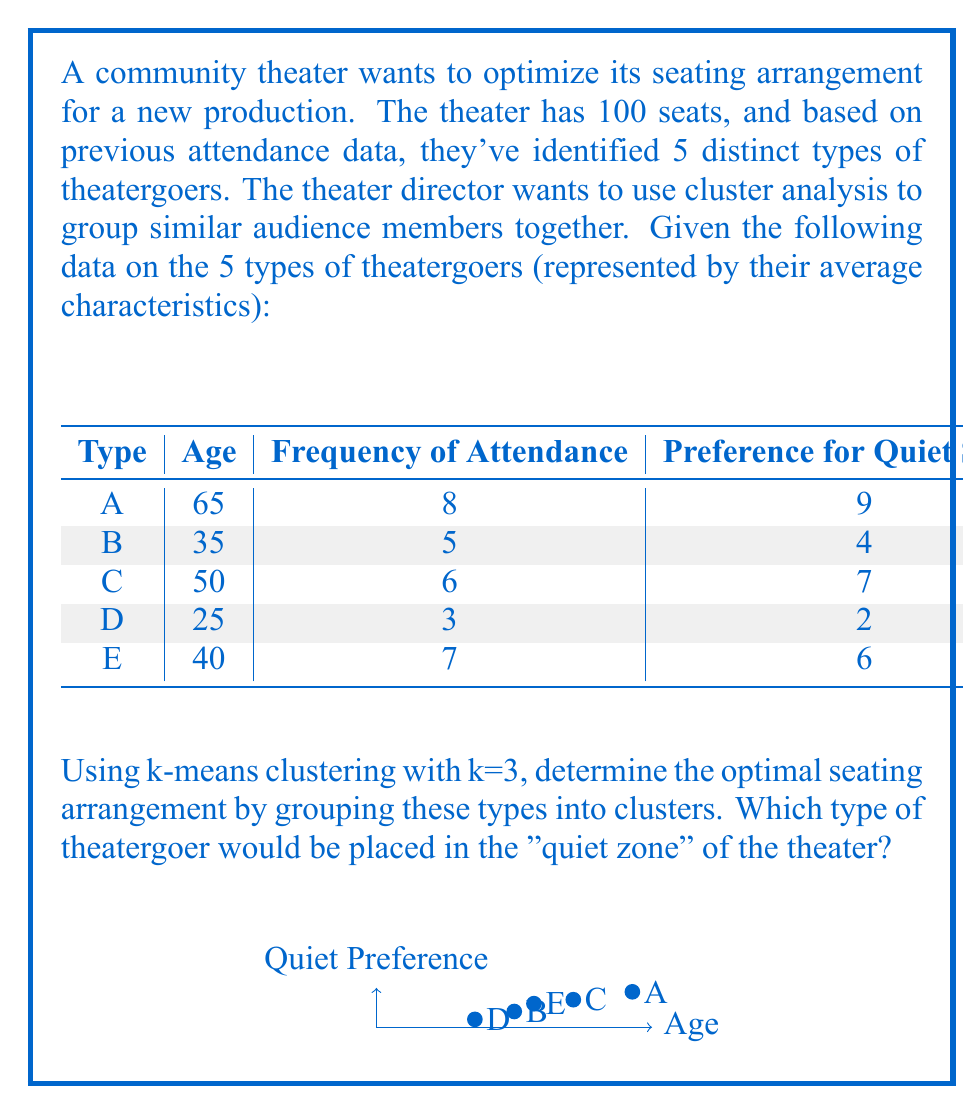Show me your answer to this math problem. To solve this problem using k-means clustering, we'll follow these steps:

1. Normalize the data to ensure all variables are on the same scale.
2. Choose initial centroids randomly.
3. Assign each point to the nearest centroid.
4. Recalculate centroids based on the new clusters.
5. Repeat steps 3-4 until convergence.

Step 1: Normalize the data
We'll use min-max normalization for age and quiet preference:

$$x_{normalized} = \frac{x - x_{min}}{x_{max} - x_{min}}$$

Normalized data:
Type | Age   | Quiet Preference
A    | 1.000 | 1.000
B    | 0.250 | 0.286
C    | 0.625 | 0.714
D    | 0.000 | 0.000
E    | 0.375 | 0.571

Step 2: Choose initial centroids (randomly)
Let's choose A, C, and E as initial centroids.

Step 3-5: Iterate until convergence

Iteration 1:
Cluster 1 (A): A
Cluster 2 (C): C
Cluster 3 (E): B, D, E

New centroids:
1: (1.000, 1.000)
2: (0.625, 0.714)
3: (0.208, 0.286)

Iteration 2:
Cluster 1 (A): A
Cluster 2 (C): C, E
Cluster 3 (B, D, E): B, D

New centroids:
1: (1.000, 1.000)
2: (0.500, 0.643)
3: (0.125, 0.143)

Iteration 3:
No changes in cluster assignments, so we've reached convergence.

Final clusters:
Cluster 1: A
Cluster 2: C, E
Cluster 3: B, D

Type A has the highest preference for quiet seating and is in its own cluster, so it would be placed in the "quiet zone" of the theater.
Answer: Type A theatergoers 